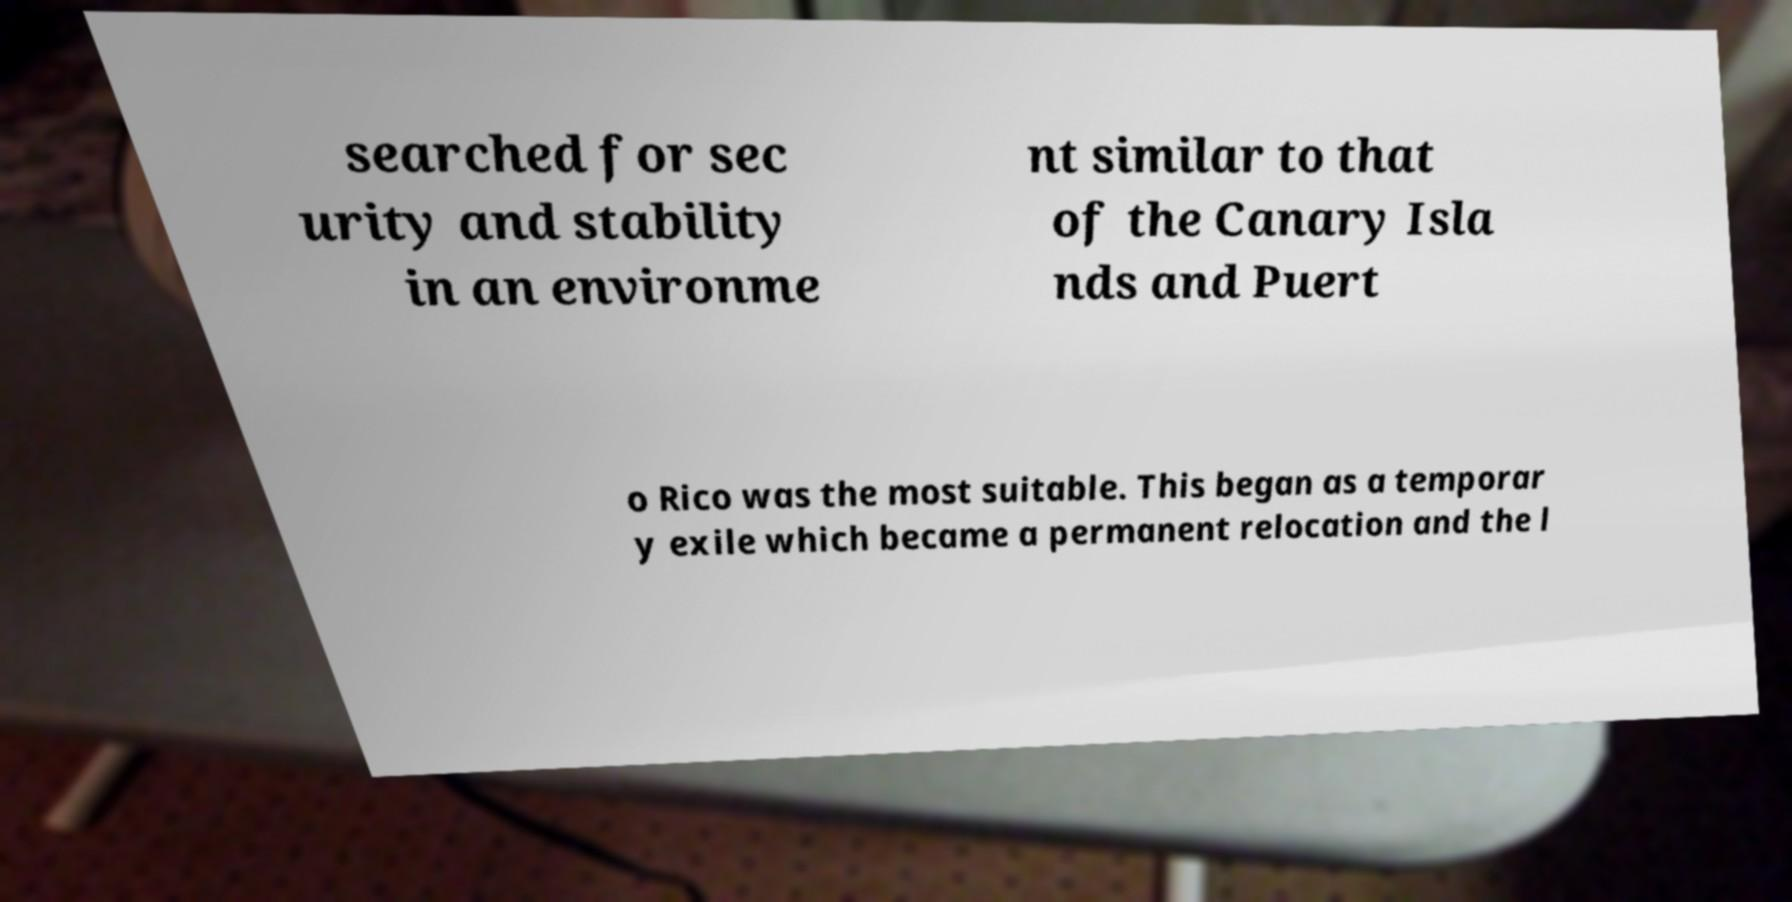Could you extract and type out the text from this image? searched for sec urity and stability in an environme nt similar to that of the Canary Isla nds and Puert o Rico was the most suitable. This began as a temporar y exile which became a permanent relocation and the l 